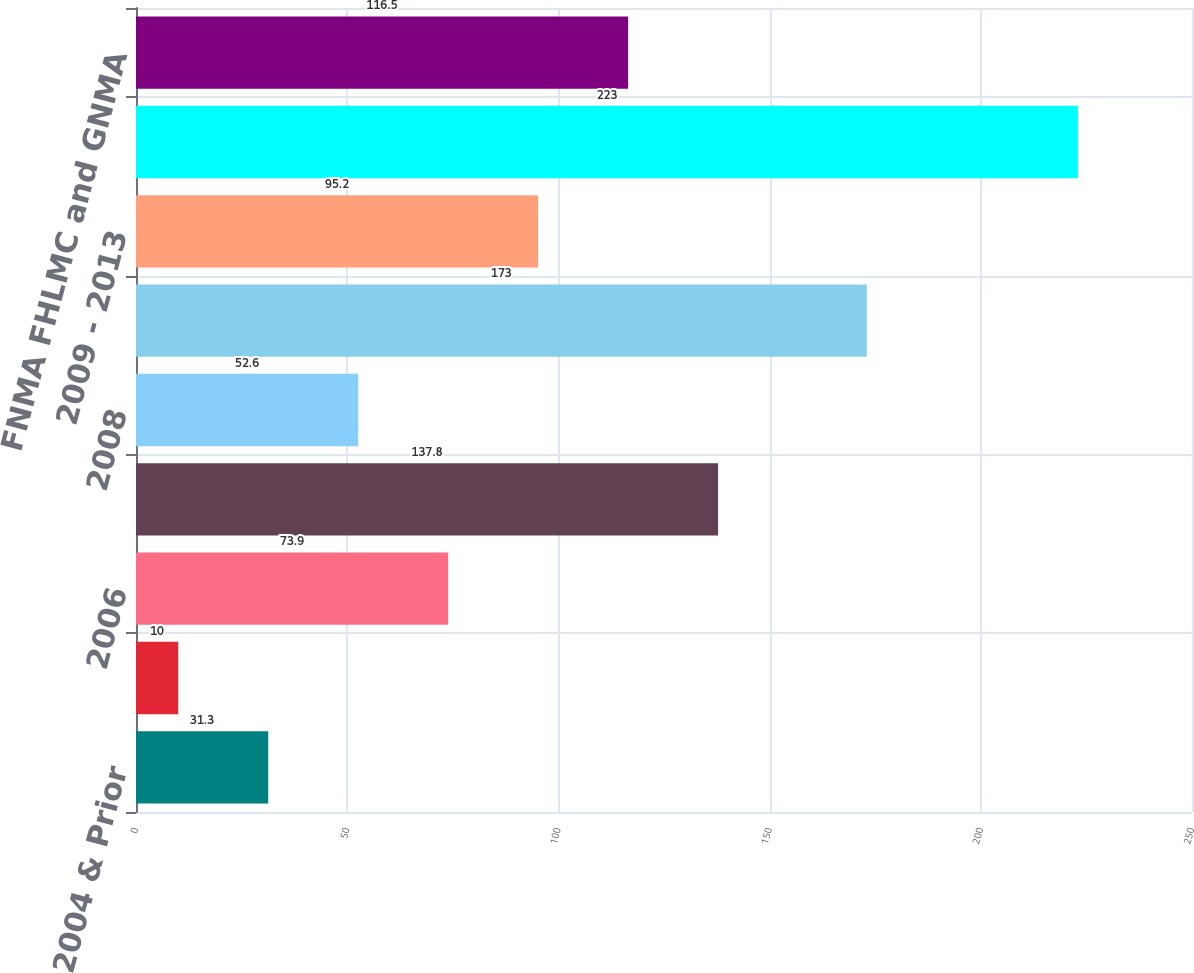Convert chart to OTSL. <chart><loc_0><loc_0><loc_500><loc_500><bar_chart><fcel>2004 & Prior<fcel>2005<fcel>2006<fcel>2007<fcel>2008<fcel>2008 & Prior<fcel>2009 - 2013<fcel>Total<fcel>FNMA FHLMC and GNMA<nl><fcel>31.3<fcel>10<fcel>73.9<fcel>137.8<fcel>52.6<fcel>173<fcel>95.2<fcel>223<fcel>116.5<nl></chart> 